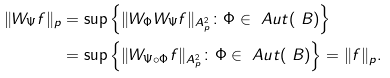Convert formula to latex. <formula><loc_0><loc_0><loc_500><loc_500>\| W _ { \Psi } f \| _ { p } & = \sup \left \{ \| W _ { \Phi } W _ { \Psi } f \| _ { A ^ { 2 } _ { p } } \colon \Phi \in \ A u t ( \ B ) \right \} \\ & = \sup \left \{ \| W _ { \Psi \circ \Phi } f \| _ { A ^ { 2 } _ { p } } \colon \Phi \in \ A u t ( \ B ) \right \} = \| f \| _ { p } .</formula> 